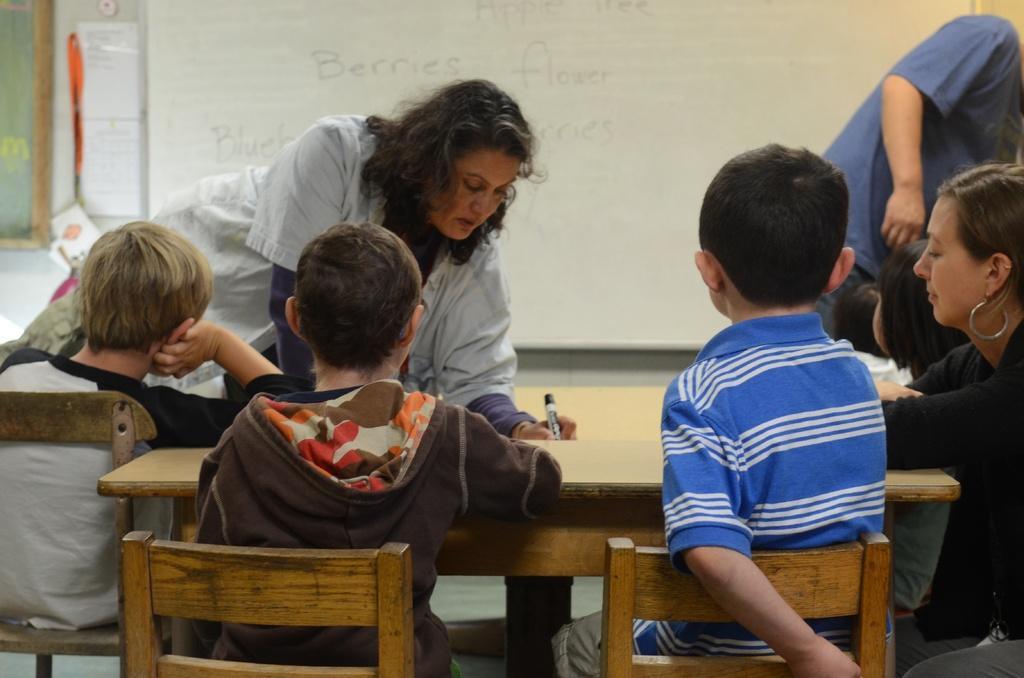Can you describe this image briefly? In this image I can see children are sitting on chairs. I can also see few people are standing. In the background I can see a white board. 